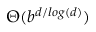Convert formula to latex. <formula><loc_0><loc_0><loc_500><loc_500>\Theta ( b ^ { d / \log ( d ) } )</formula> 